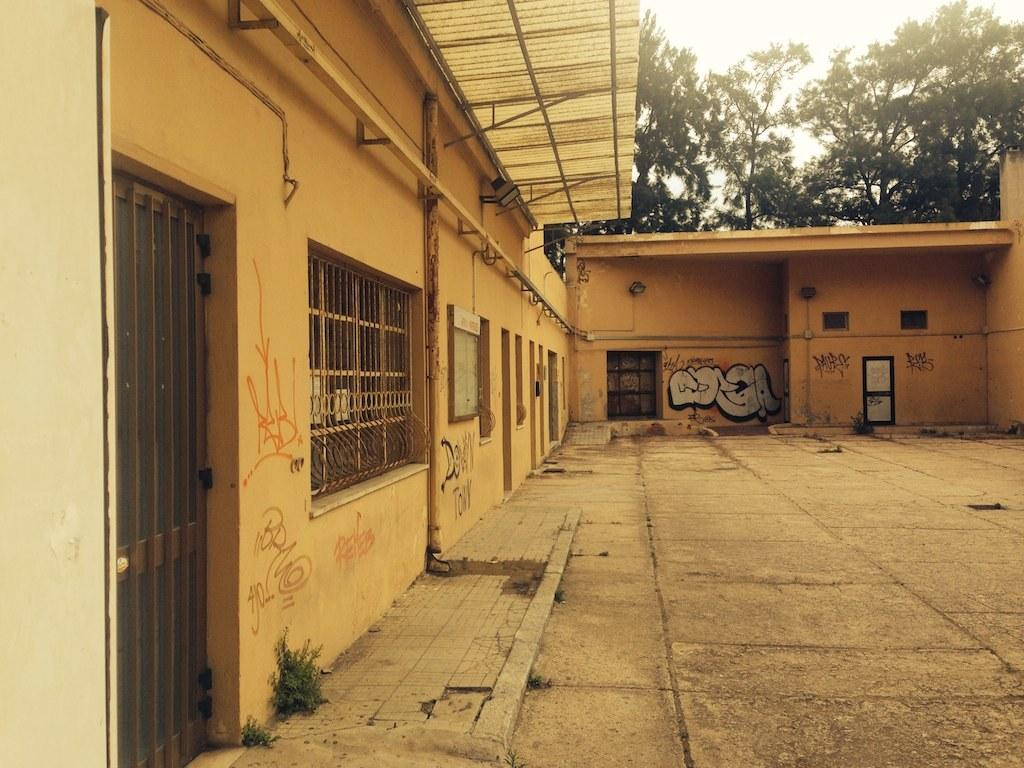What type of view is shown in the image? The image is an outside view. What is located on the left side of the image? There is a wall on the left side of the image. What features can be seen on the wall? The wall has doors and windows. What can be seen in the background of the image? There are trees in the background of the image. What is visible at the top of the image? The sky is visible at the top of the image. How many accounts are visible in the image? There are no accounts present in the image; it is an outside view of a wall with doors and windows. Can you see a flock of birds flying in the image? There is no mention of birds or a flock in the image; it features a wall with doors and windows, trees in the background, and the sky visible at the top. 